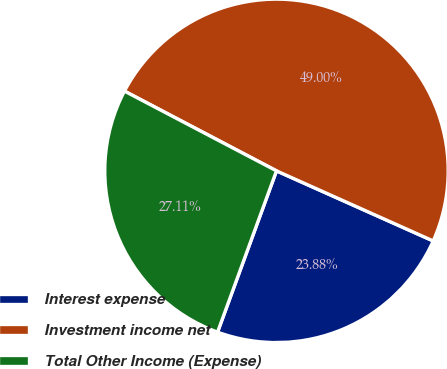<chart> <loc_0><loc_0><loc_500><loc_500><pie_chart><fcel>Interest expense<fcel>Investment income net<fcel>Total Other Income (Expense)<nl><fcel>23.88%<fcel>49.0%<fcel>27.11%<nl></chart> 